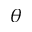<formula> <loc_0><loc_0><loc_500><loc_500>\theta</formula> 